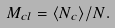Convert formula to latex. <formula><loc_0><loc_0><loc_500><loc_500>M _ { c l } = \langle N _ { c } \rangle / N .</formula> 